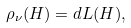Convert formula to latex. <formula><loc_0><loc_0><loc_500><loc_500>\rho _ { \nu } ( H ) = d L ( H ) ,</formula> 